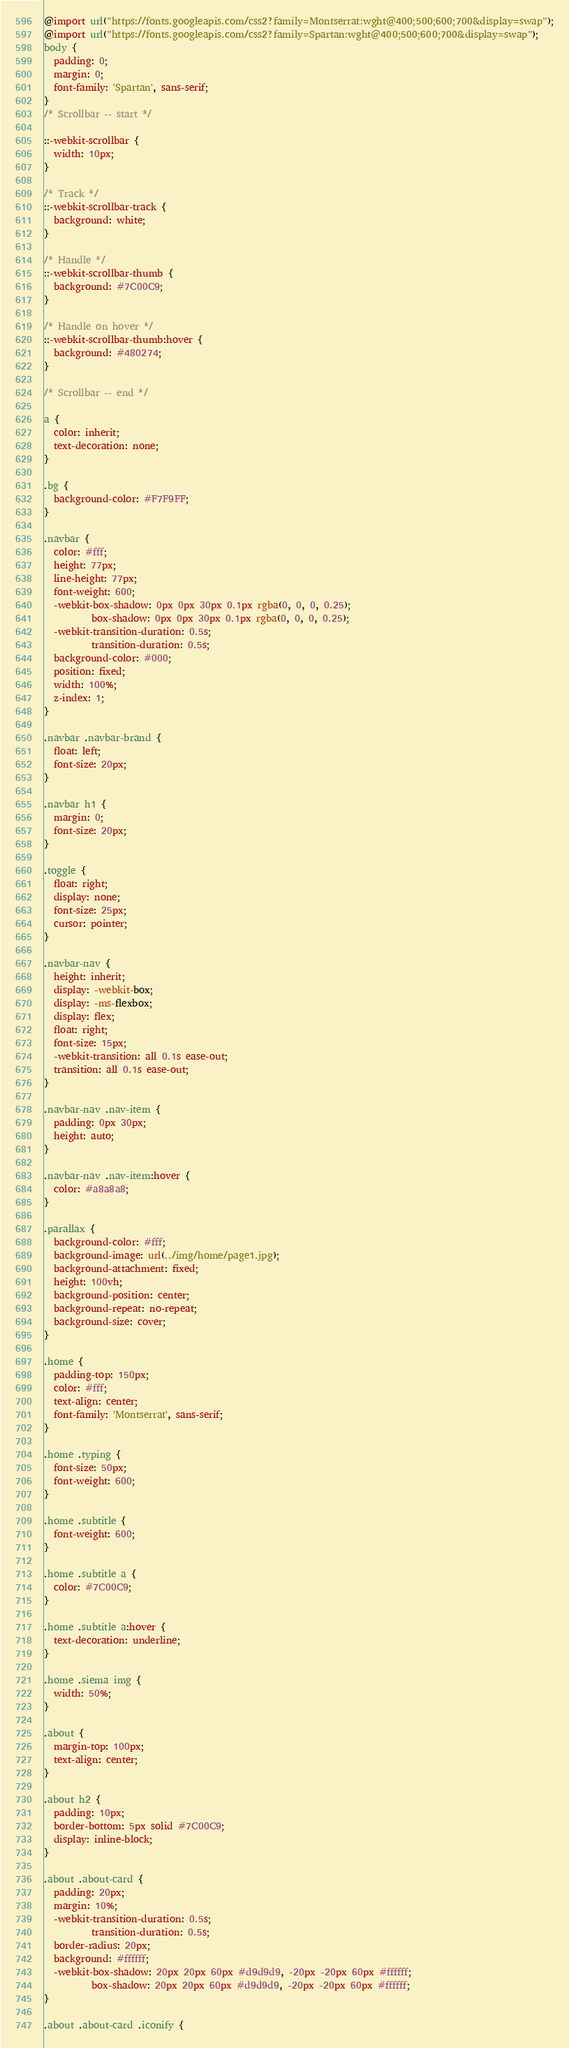Convert code to text. <code><loc_0><loc_0><loc_500><loc_500><_CSS_>@import url("https://fonts.googleapis.com/css2?family=Montserrat:wght@400;500;600;700&display=swap");
@import url("https://fonts.googleapis.com/css2?family=Spartan:wght@400;500;600;700&display=swap");
body {
  padding: 0;
  margin: 0;
  font-family: 'Spartan', sans-serif;
}
/* Scrollbar -- start */

::-webkit-scrollbar {
  width: 10px;
}

/* Track */
::-webkit-scrollbar-track {
  background: white; 
}
 
/* Handle */
::-webkit-scrollbar-thumb {
  background: #7C00C9; 
}

/* Handle on hover */
::-webkit-scrollbar-thumb:hover {
  background: #480274; 
}

/* Scrollbar -- end */

a {
  color: inherit;
  text-decoration: none;
}

.bg {
  background-color: #F7F9FF;
}

.navbar {
  color: #fff;
  height: 77px;
  line-height: 77px;
  font-weight: 600;
  -webkit-box-shadow: 0px 0px 30px 0.1px rgba(0, 0, 0, 0.25);
          box-shadow: 0px 0px 30px 0.1px rgba(0, 0, 0, 0.25);
  -webkit-transition-duration: 0.5s;
          transition-duration: 0.5s;
  background-color: #000;
  position: fixed;
  width: 100%;
  z-index: 1;
}

.navbar .navbar-brand {
  float: left;
  font-size: 20px;
}

.navbar h1 {
  margin: 0;
  font-size: 20px;
}

.toggle {
  float: right;
  display: none;
  font-size: 25px;
  cursor: pointer;
}

.navbar-nav {
  height: inherit;
  display: -webkit-box;
  display: -ms-flexbox;
  display: flex;
  float: right;
  font-size: 15px;
  -webkit-transition: all 0.1s ease-out;
  transition: all 0.1s ease-out;
}

.navbar-nav .nav-item {
  padding: 0px 30px;
  height: auto;
}

.navbar-nav .nav-item:hover {
  color: #a8a8a8;
}

.parallax {
  background-color: #fff;
  background-image: url(../img/home/page1.jpg);
  background-attachment: fixed;
  height: 100vh;
  background-position: center;
  background-repeat: no-repeat;
  background-size: cover;
}

.home {
  padding-top: 150px;
  color: #fff;
  text-align: center;
  font-family: 'Montserrat', sans-serif;
}

.home .typing {
  font-size: 50px;
  font-weight: 600;
}

.home .subtitle {
  font-weight: 600;
}

.home .subtitle a {
  color: #7C00C9;
}

.home .subtitle a:hover {
  text-decoration: underline;
}

.home .siema img {
  width: 50%;
}

.about {
  margin-top: 100px;
  text-align: center;
}

.about h2 {
  padding: 10px;
  border-bottom: 5px solid #7C00C9;
  display: inline-block;
}

.about .about-card {
  padding: 20px;
  margin: 10%;
  -webkit-transition-duration: 0.5s;
          transition-duration: 0.5s;
  border-radius: 20px;
  background: #ffffff;
  -webkit-box-shadow: 20px 20px 60px #d9d9d9, -20px -20px 60px #ffffff;
          box-shadow: 20px 20px 60px #d9d9d9, -20px -20px 60px #ffffff;
}

.about .about-card .iconify {</code> 